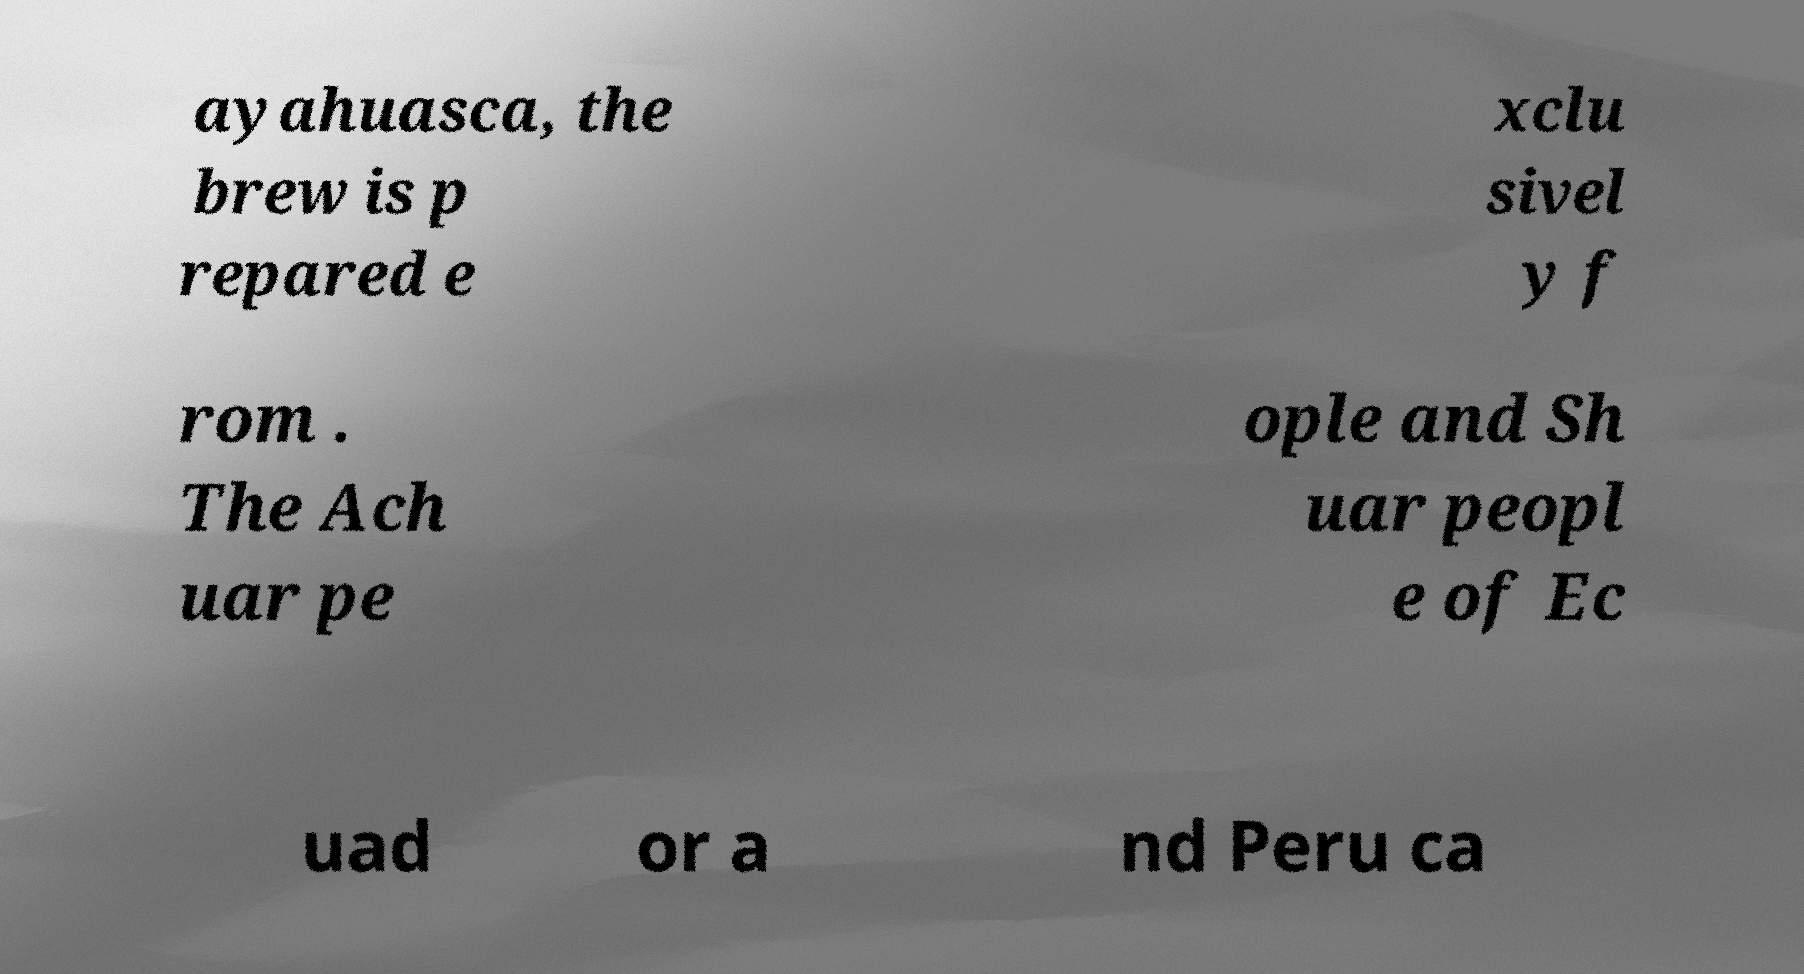For documentation purposes, I need the text within this image transcribed. Could you provide that? ayahuasca, the brew is p repared e xclu sivel y f rom . The Ach uar pe ople and Sh uar peopl e of Ec uad or a nd Peru ca 